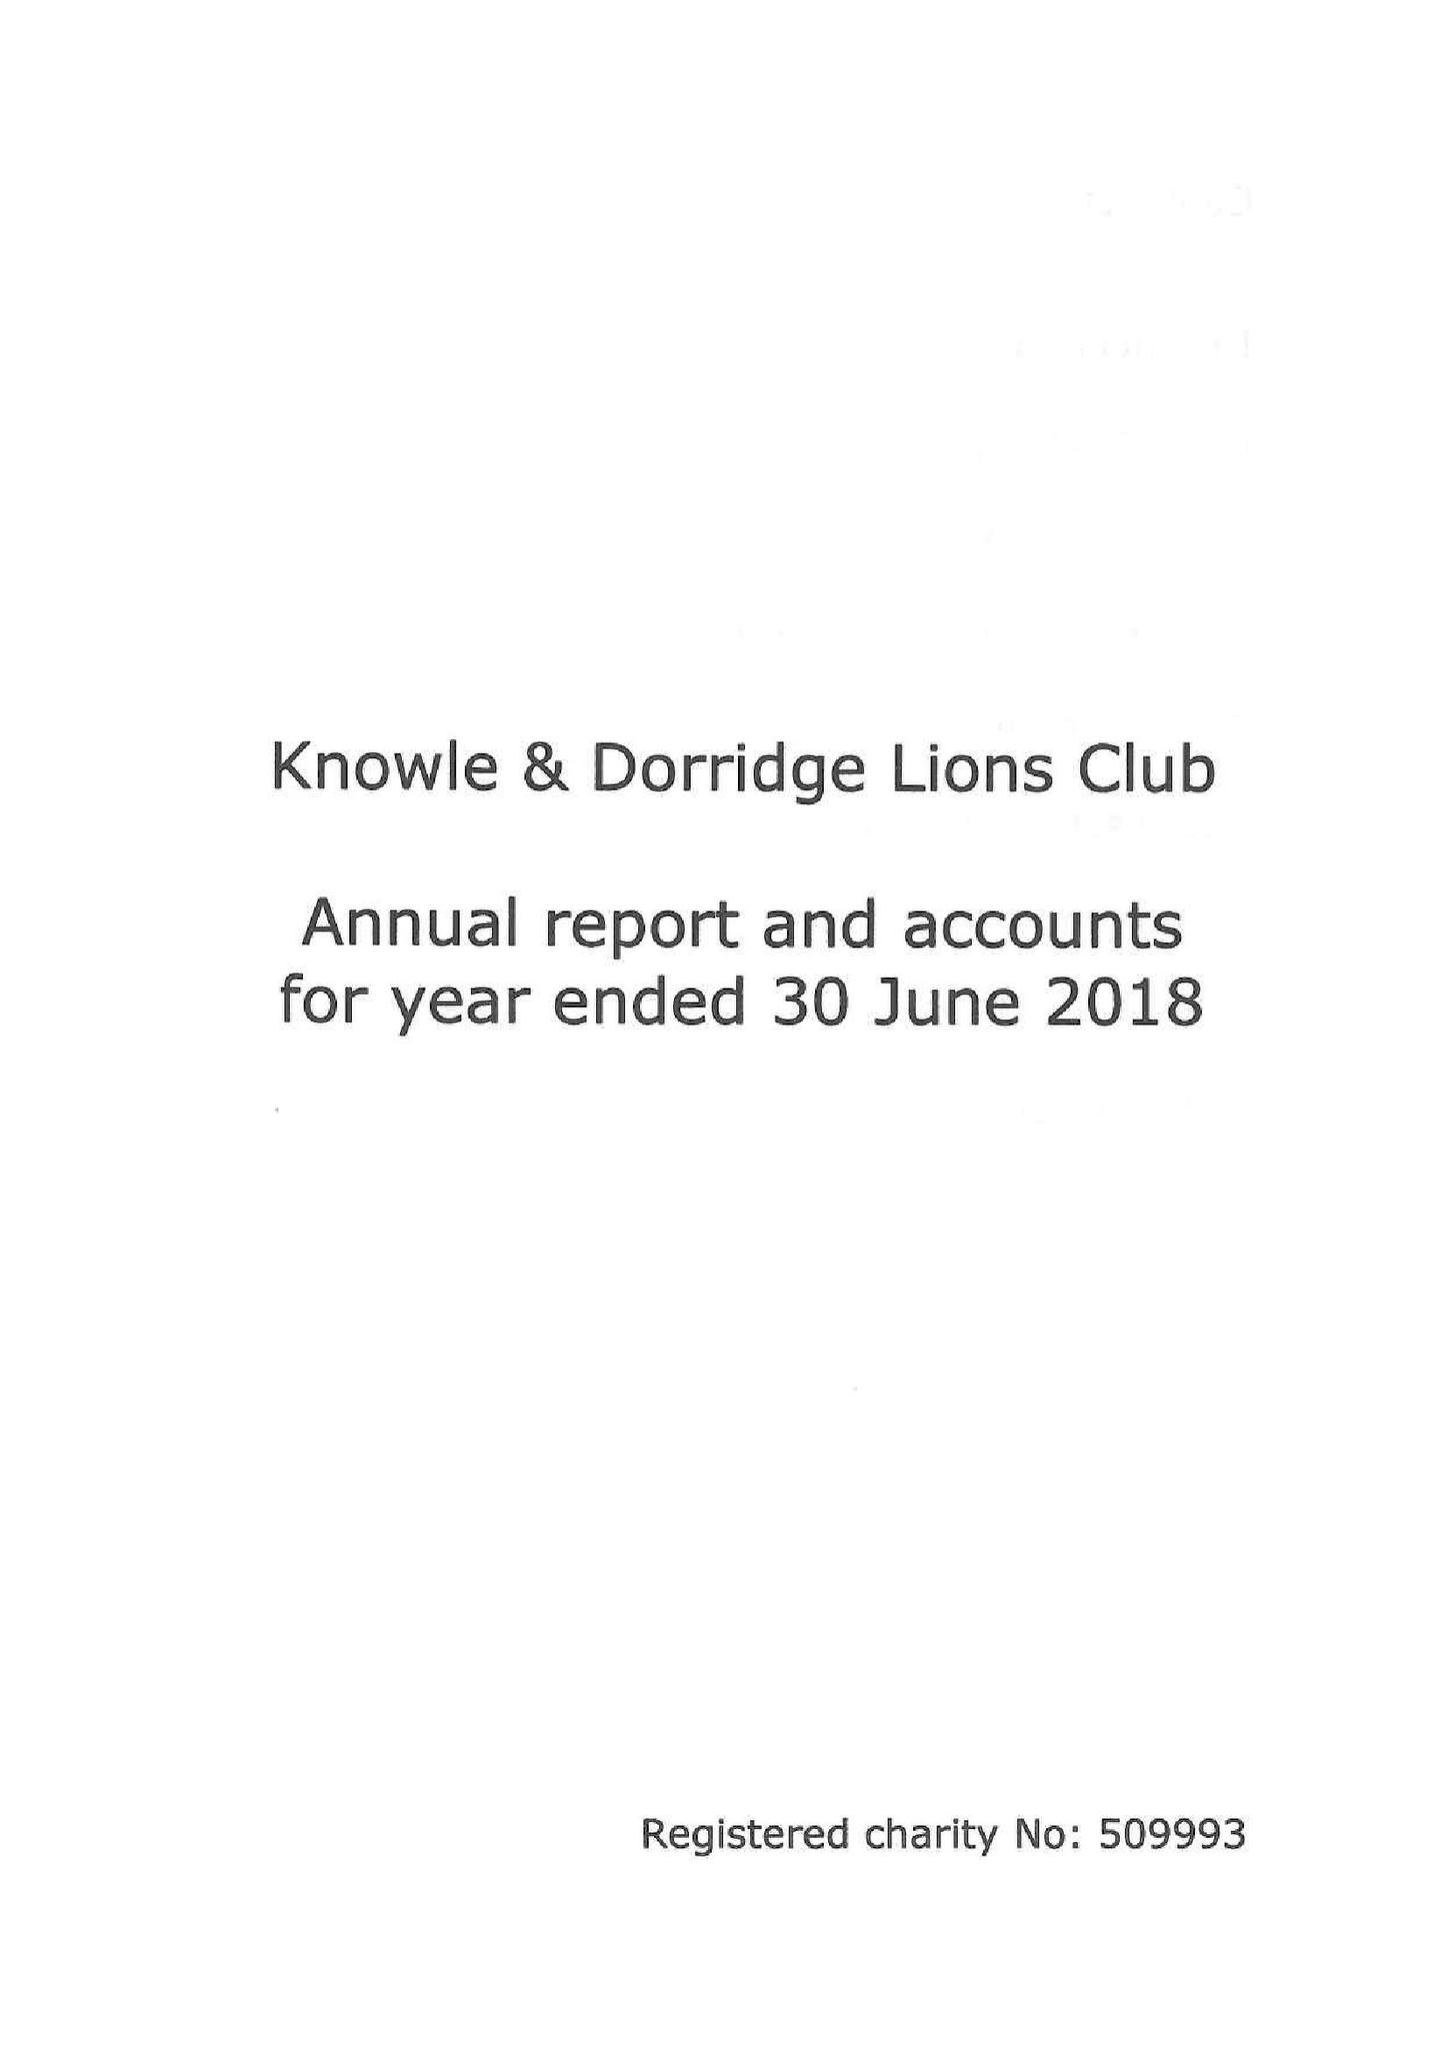What is the value for the address__street_line?
Answer the question using a single word or phrase. 17 HALLCROFT WAY 